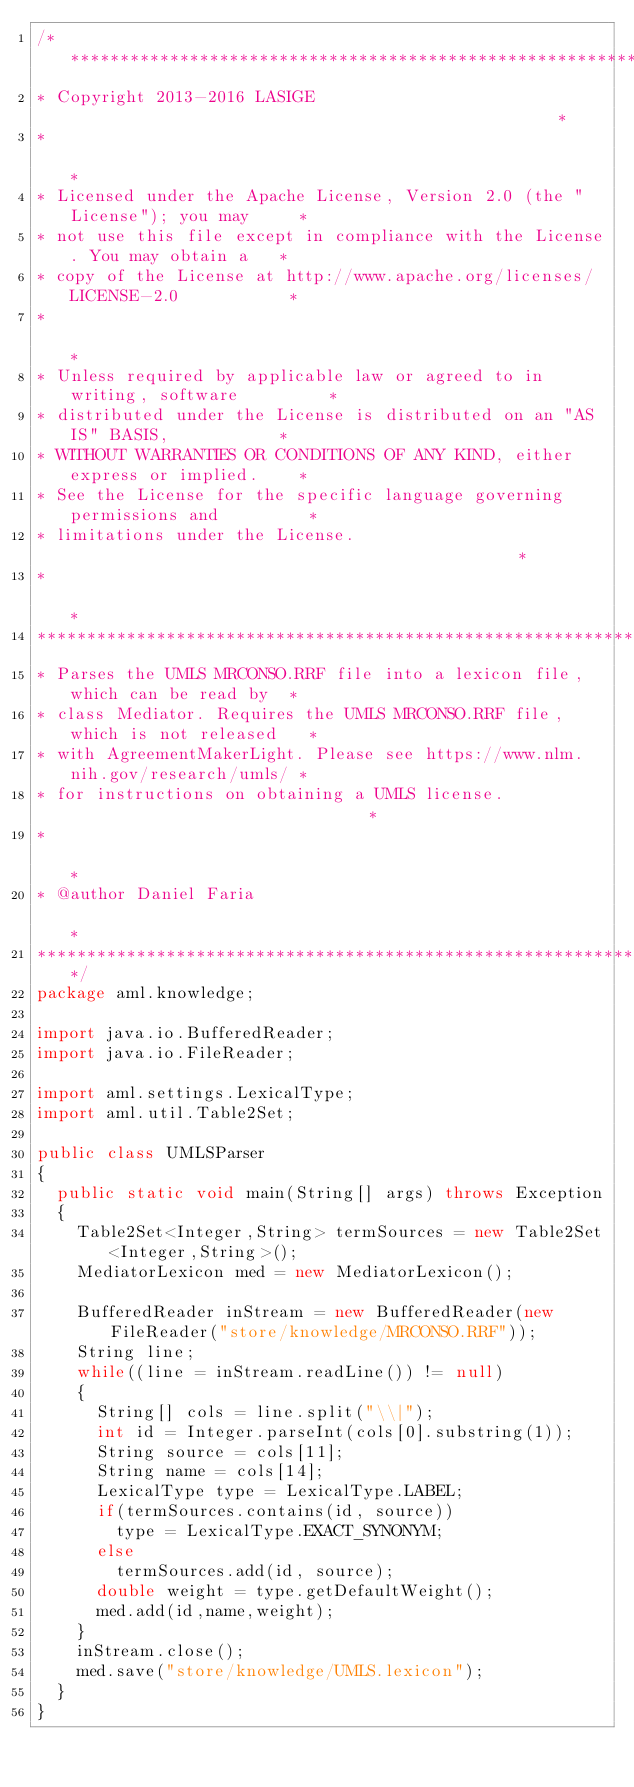<code> <loc_0><loc_0><loc_500><loc_500><_Java_>/******************************************************************************
* Copyright 2013-2016 LASIGE                                                  *
*                                                                             *
* Licensed under the Apache License, Version 2.0 (the "License"); you may     *
* not use this file except in compliance with the License. You may obtain a   *
* copy of the License at http://www.apache.org/licenses/LICENSE-2.0           *
*                                                                             *
* Unless required by applicable law or agreed to in writing, software         *
* distributed under the License is distributed on an "AS IS" BASIS,           *
* WITHOUT WARRANTIES OR CONDITIONS OF ANY KIND, either express or implied.    *
* See the License for the specific language governing permissions and         *
* limitations under the License.                                              *
*                                                                             *
*******************************************************************************
* Parses the UMLS MRCONSO.RRF file into a lexicon file, which can be read by  *
* class Mediator. Requires the UMLS MRCONSO.RRF file, which is not released   *
* with AgreementMakerLight. Please see https://www.nlm.nih.gov/research/umls/ *
* for instructions on obtaining a UMLS license.                               * 
*                                                                             *
* @author Daniel Faria                                                        *
******************************************************************************/
package aml.knowledge;

import java.io.BufferedReader;
import java.io.FileReader;

import aml.settings.LexicalType;
import aml.util.Table2Set;

public class UMLSParser
{
	public static void main(String[] args) throws Exception
	{
		Table2Set<Integer,String> termSources = new Table2Set<Integer,String>();
		MediatorLexicon med = new MediatorLexicon();
		
		BufferedReader inStream = new BufferedReader(new FileReader("store/knowledge/MRCONSO.RRF"));
		String line;
		while((line = inStream.readLine()) != null)
		{
			String[] cols = line.split("\\|");
			int id = Integer.parseInt(cols[0].substring(1));
			String source = cols[11];
			String name = cols[14];
			LexicalType type = LexicalType.LABEL;
			if(termSources.contains(id, source))
				type = LexicalType.EXACT_SYNONYM;
			else
				termSources.add(id, source);
			double weight = type.getDefaultWeight();
			med.add(id,name,weight);
		}
		inStream.close();
		med.save("store/knowledge/UMLS.lexicon");
	}
}</code> 